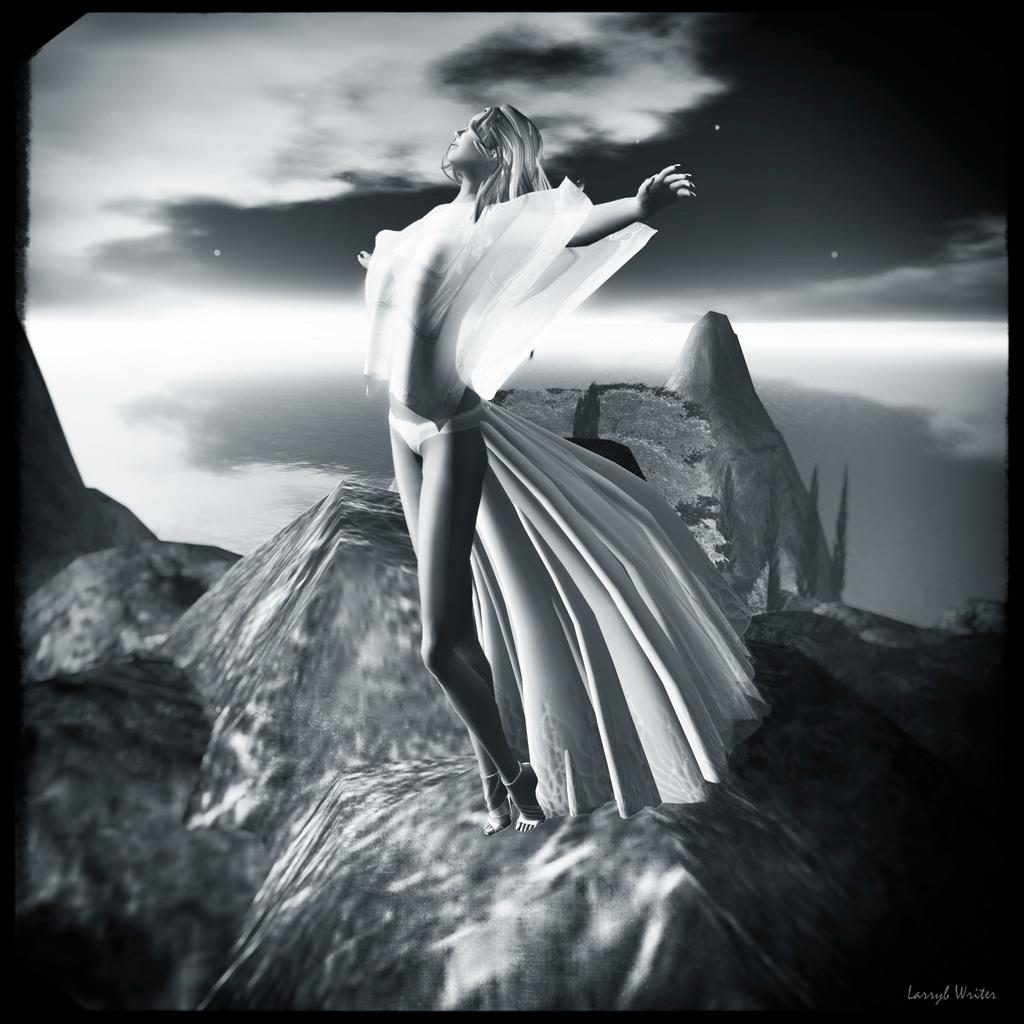What type of image is being described? The image is animated. What is the woman in the image doing? The woman is standing on a rock. What can be seen in the background of the image? There is sky visible in the background of the image. How many eggs are being digested by the cats in the image? There are no cats or eggs present in the image; it features an animated scene with a woman standing on a rock. 